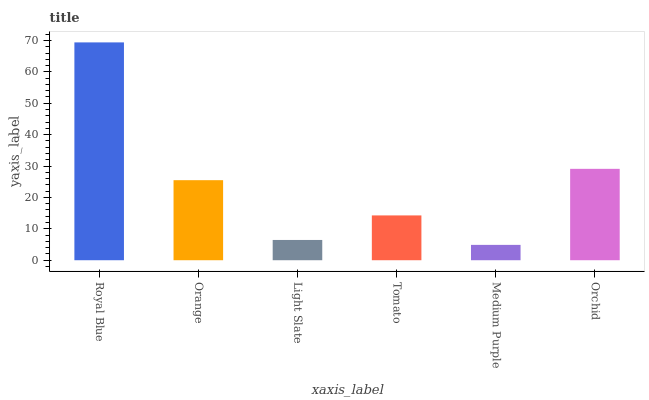Is Medium Purple the minimum?
Answer yes or no. Yes. Is Royal Blue the maximum?
Answer yes or no. Yes. Is Orange the minimum?
Answer yes or no. No. Is Orange the maximum?
Answer yes or no. No. Is Royal Blue greater than Orange?
Answer yes or no. Yes. Is Orange less than Royal Blue?
Answer yes or no. Yes. Is Orange greater than Royal Blue?
Answer yes or no. No. Is Royal Blue less than Orange?
Answer yes or no. No. Is Orange the high median?
Answer yes or no. Yes. Is Tomato the low median?
Answer yes or no. Yes. Is Tomato the high median?
Answer yes or no. No. Is Orange the low median?
Answer yes or no. No. 